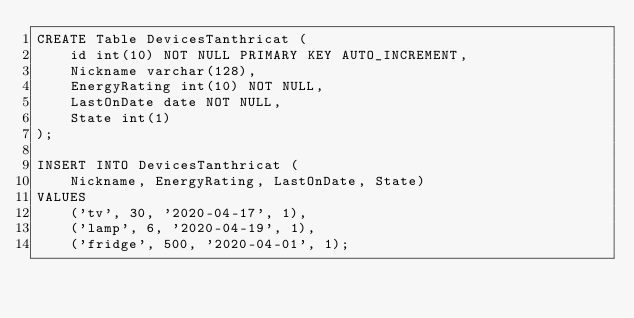Convert code to text. <code><loc_0><loc_0><loc_500><loc_500><_SQL_>CREATE Table DevicesTanthricat (
    id int(10) NOT NULL PRIMARY KEY AUTO_INCREMENT,
    Nickname varchar(128),
    EnergyRating int(10) NOT NULL,
    LastOnDate date NOT NULL,
    State int(1)
);

INSERT INTO DevicesTanthricat (
    Nickname, EnergyRating, LastOnDate, State)
VALUES
    ('tv', 30, '2020-04-17', 1),
    ('lamp', 6, '2020-04-19', 1),
    ('fridge', 500, '2020-04-01', 1);</code> 